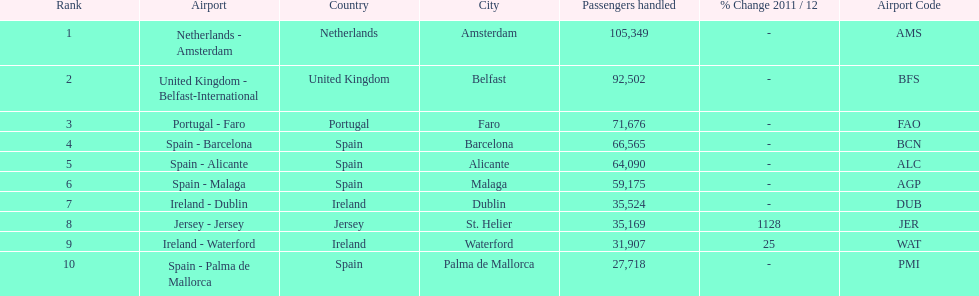How many passengers are going to or coming from spain? 217,548. 